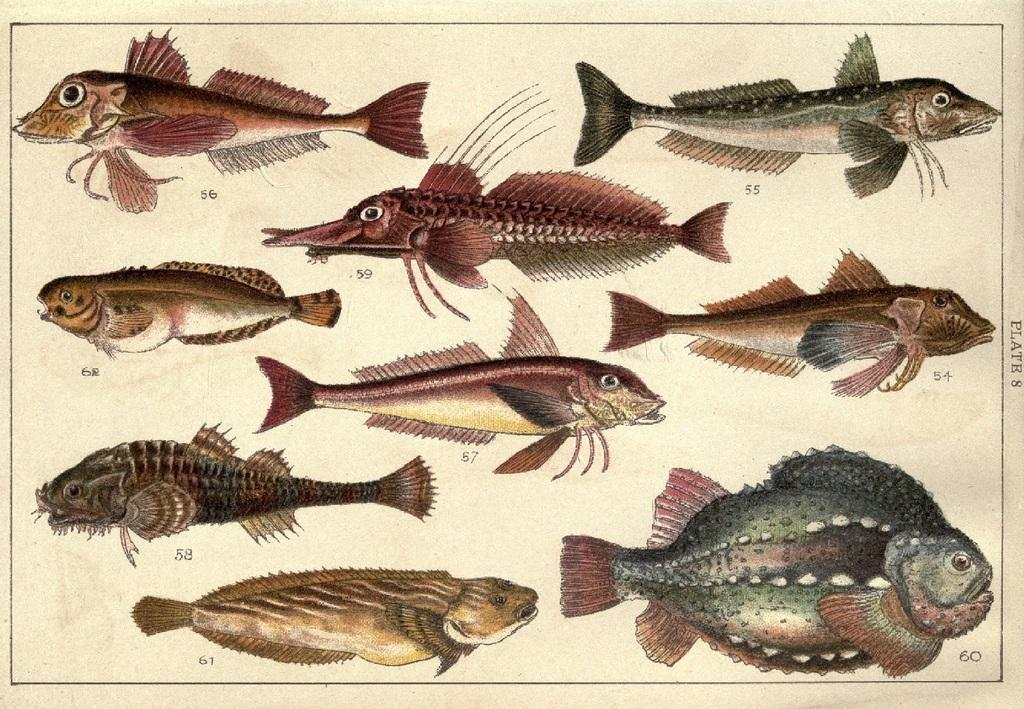What is the main subject of the image? The main subject of the image is a paper. What can be seen on the paper? The paper has different kinds of fish pictures printed on it. What type of stove can be seen in the image? There is no stove present in the image; it features a paper with fish pictures. Is the minister present in the image? There is no minister present in the image; it features a paper with fish pictures. 